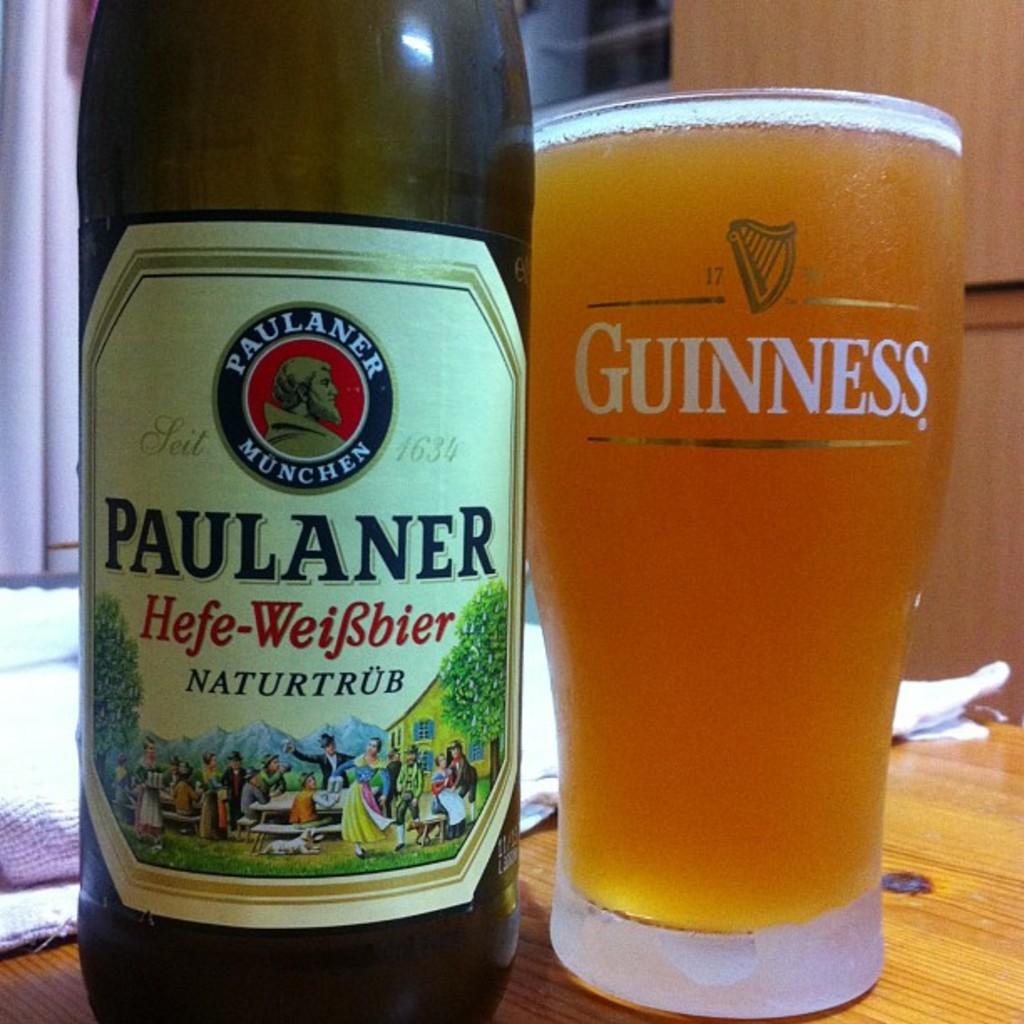What brand is this beer?
Make the answer very short. Paulaner. What does the glass say?
Your response must be concise. Guinness. 